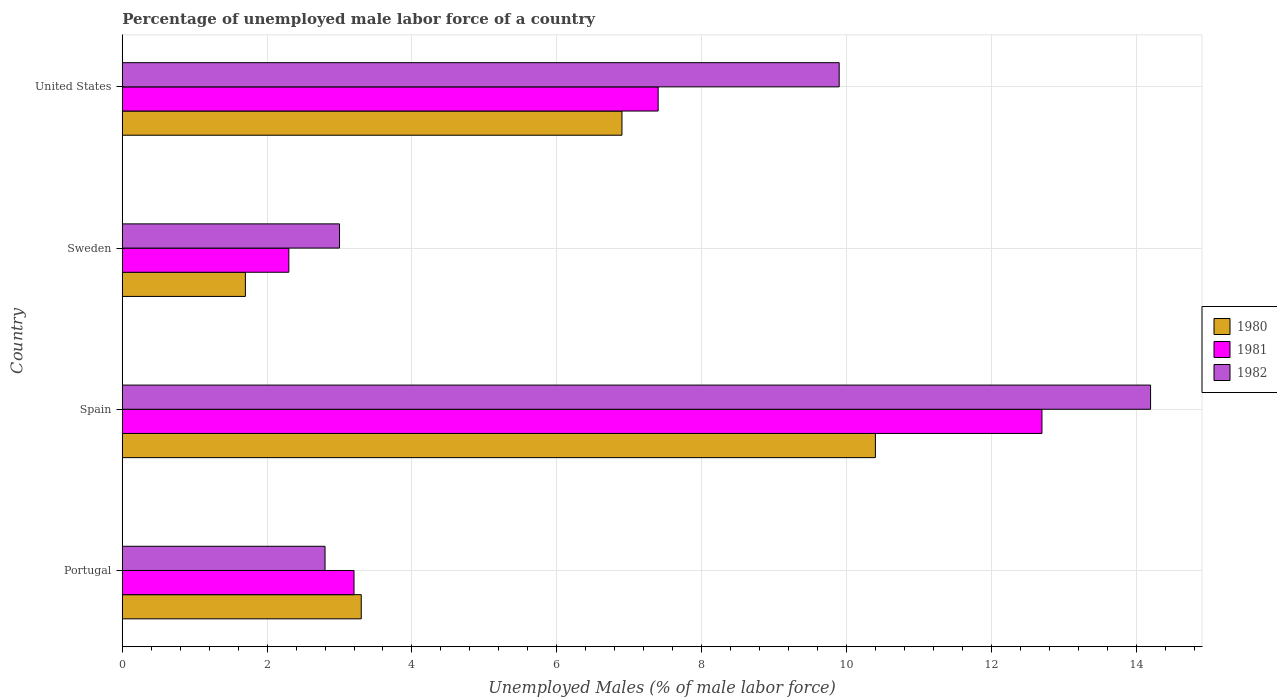How many different coloured bars are there?
Ensure brevity in your answer.  3. How many groups of bars are there?
Offer a terse response. 4. Are the number of bars per tick equal to the number of legend labels?
Keep it short and to the point. Yes. What is the percentage of unemployed male labor force in 1980 in Spain?
Make the answer very short. 10.4. Across all countries, what is the maximum percentage of unemployed male labor force in 1982?
Offer a terse response. 14.2. Across all countries, what is the minimum percentage of unemployed male labor force in 1982?
Give a very brief answer. 2.8. In which country was the percentage of unemployed male labor force in 1982 maximum?
Offer a terse response. Spain. In which country was the percentage of unemployed male labor force in 1982 minimum?
Give a very brief answer. Portugal. What is the total percentage of unemployed male labor force in 1980 in the graph?
Ensure brevity in your answer.  22.3. What is the difference between the percentage of unemployed male labor force in 1981 in Sweden and that in United States?
Your answer should be compact. -5.1. What is the difference between the percentage of unemployed male labor force in 1980 in United States and the percentage of unemployed male labor force in 1982 in Portugal?
Provide a succinct answer. 4.1. What is the average percentage of unemployed male labor force in 1981 per country?
Your answer should be very brief. 6.4. What is the difference between the percentage of unemployed male labor force in 1980 and percentage of unemployed male labor force in 1981 in Sweden?
Give a very brief answer. -0.6. In how many countries, is the percentage of unemployed male labor force in 1981 greater than 4 %?
Give a very brief answer. 2. What is the ratio of the percentage of unemployed male labor force in 1981 in Portugal to that in Sweden?
Your response must be concise. 1.39. What is the difference between the highest and the second highest percentage of unemployed male labor force in 1981?
Keep it short and to the point. 5.3. What is the difference between the highest and the lowest percentage of unemployed male labor force in 1982?
Keep it short and to the point. 11.4. In how many countries, is the percentage of unemployed male labor force in 1981 greater than the average percentage of unemployed male labor force in 1981 taken over all countries?
Offer a terse response. 2. What does the 3rd bar from the top in Portugal represents?
Provide a succinct answer. 1980. What does the 1st bar from the bottom in United States represents?
Ensure brevity in your answer.  1980. Is it the case that in every country, the sum of the percentage of unemployed male labor force in 1980 and percentage of unemployed male labor force in 1982 is greater than the percentage of unemployed male labor force in 1981?
Offer a very short reply. Yes. How many bars are there?
Offer a very short reply. 12. Are all the bars in the graph horizontal?
Give a very brief answer. Yes. What is the difference between two consecutive major ticks on the X-axis?
Give a very brief answer. 2. Does the graph contain any zero values?
Offer a very short reply. No. How many legend labels are there?
Your answer should be very brief. 3. How are the legend labels stacked?
Your response must be concise. Vertical. What is the title of the graph?
Your response must be concise. Percentage of unemployed male labor force of a country. Does "1988" appear as one of the legend labels in the graph?
Your response must be concise. No. What is the label or title of the X-axis?
Ensure brevity in your answer.  Unemployed Males (% of male labor force). What is the Unemployed Males (% of male labor force) of 1980 in Portugal?
Offer a very short reply. 3.3. What is the Unemployed Males (% of male labor force) of 1981 in Portugal?
Provide a short and direct response. 3.2. What is the Unemployed Males (% of male labor force) of 1982 in Portugal?
Keep it short and to the point. 2.8. What is the Unemployed Males (% of male labor force) of 1980 in Spain?
Your answer should be very brief. 10.4. What is the Unemployed Males (% of male labor force) of 1981 in Spain?
Offer a very short reply. 12.7. What is the Unemployed Males (% of male labor force) of 1982 in Spain?
Offer a very short reply. 14.2. What is the Unemployed Males (% of male labor force) of 1980 in Sweden?
Your response must be concise. 1.7. What is the Unemployed Males (% of male labor force) in 1981 in Sweden?
Your answer should be compact. 2.3. What is the Unemployed Males (% of male labor force) in 1982 in Sweden?
Your answer should be very brief. 3. What is the Unemployed Males (% of male labor force) in 1980 in United States?
Your answer should be very brief. 6.9. What is the Unemployed Males (% of male labor force) in 1981 in United States?
Provide a succinct answer. 7.4. What is the Unemployed Males (% of male labor force) in 1982 in United States?
Provide a short and direct response. 9.9. Across all countries, what is the maximum Unemployed Males (% of male labor force) in 1980?
Your answer should be very brief. 10.4. Across all countries, what is the maximum Unemployed Males (% of male labor force) of 1981?
Make the answer very short. 12.7. Across all countries, what is the maximum Unemployed Males (% of male labor force) in 1982?
Give a very brief answer. 14.2. Across all countries, what is the minimum Unemployed Males (% of male labor force) of 1980?
Make the answer very short. 1.7. Across all countries, what is the minimum Unemployed Males (% of male labor force) in 1981?
Offer a terse response. 2.3. Across all countries, what is the minimum Unemployed Males (% of male labor force) in 1982?
Ensure brevity in your answer.  2.8. What is the total Unemployed Males (% of male labor force) in 1980 in the graph?
Ensure brevity in your answer.  22.3. What is the total Unemployed Males (% of male labor force) of 1981 in the graph?
Offer a terse response. 25.6. What is the total Unemployed Males (% of male labor force) of 1982 in the graph?
Offer a very short reply. 29.9. What is the difference between the Unemployed Males (% of male labor force) of 1981 in Portugal and that in Spain?
Keep it short and to the point. -9.5. What is the difference between the Unemployed Males (% of male labor force) in 1982 in Portugal and that in Spain?
Give a very brief answer. -11.4. What is the difference between the Unemployed Males (% of male labor force) of 1980 in Portugal and that in Sweden?
Your answer should be compact. 1.6. What is the difference between the Unemployed Males (% of male labor force) in 1980 in Portugal and that in United States?
Offer a terse response. -3.6. What is the difference between the Unemployed Males (% of male labor force) in 1981 in Portugal and that in United States?
Keep it short and to the point. -4.2. What is the difference between the Unemployed Males (% of male labor force) in 1980 in Spain and that in Sweden?
Provide a succinct answer. 8.7. What is the difference between the Unemployed Males (% of male labor force) of 1981 in Spain and that in Sweden?
Offer a terse response. 10.4. What is the difference between the Unemployed Males (% of male labor force) of 1982 in Spain and that in Sweden?
Keep it short and to the point. 11.2. What is the difference between the Unemployed Males (% of male labor force) in 1981 in Spain and that in United States?
Your response must be concise. 5.3. What is the difference between the Unemployed Males (% of male labor force) of 1981 in Sweden and that in United States?
Provide a succinct answer. -5.1. What is the difference between the Unemployed Males (% of male labor force) in 1980 in Portugal and the Unemployed Males (% of male labor force) in 1981 in Spain?
Give a very brief answer. -9.4. What is the difference between the Unemployed Males (% of male labor force) in 1981 in Portugal and the Unemployed Males (% of male labor force) in 1982 in Spain?
Offer a very short reply. -11. What is the difference between the Unemployed Males (% of male labor force) in 1980 in Portugal and the Unemployed Males (% of male labor force) in 1981 in Sweden?
Your answer should be very brief. 1. What is the difference between the Unemployed Males (% of male labor force) in 1980 in Portugal and the Unemployed Males (% of male labor force) in 1982 in Sweden?
Your answer should be very brief. 0.3. What is the difference between the Unemployed Males (% of male labor force) in 1980 in Portugal and the Unemployed Males (% of male labor force) in 1981 in United States?
Keep it short and to the point. -4.1. What is the difference between the Unemployed Males (% of male labor force) in 1980 in Portugal and the Unemployed Males (% of male labor force) in 1982 in United States?
Provide a short and direct response. -6.6. What is the difference between the Unemployed Males (% of male labor force) in 1981 in Portugal and the Unemployed Males (% of male labor force) in 1982 in United States?
Offer a terse response. -6.7. What is the difference between the Unemployed Males (% of male labor force) in 1980 in Spain and the Unemployed Males (% of male labor force) in 1981 in Sweden?
Your answer should be very brief. 8.1. What is the difference between the Unemployed Males (% of male labor force) of 1980 in Spain and the Unemployed Males (% of male labor force) of 1982 in Sweden?
Provide a short and direct response. 7.4. What is the difference between the Unemployed Males (% of male labor force) of 1981 in Spain and the Unemployed Males (% of male labor force) of 1982 in Sweden?
Your answer should be very brief. 9.7. What is the difference between the Unemployed Males (% of male labor force) of 1980 in Spain and the Unemployed Males (% of male labor force) of 1982 in United States?
Keep it short and to the point. 0.5. What is the difference between the Unemployed Males (% of male labor force) in 1981 in Spain and the Unemployed Males (% of male labor force) in 1982 in United States?
Your answer should be very brief. 2.8. What is the difference between the Unemployed Males (% of male labor force) of 1981 in Sweden and the Unemployed Males (% of male labor force) of 1982 in United States?
Offer a very short reply. -7.6. What is the average Unemployed Males (% of male labor force) of 1980 per country?
Provide a short and direct response. 5.58. What is the average Unemployed Males (% of male labor force) of 1982 per country?
Ensure brevity in your answer.  7.47. What is the difference between the Unemployed Males (% of male labor force) in 1980 and Unemployed Males (% of male labor force) in 1981 in Portugal?
Provide a short and direct response. 0.1. What is the difference between the Unemployed Males (% of male labor force) in 1981 and Unemployed Males (% of male labor force) in 1982 in Portugal?
Offer a very short reply. 0.4. What is the difference between the Unemployed Males (% of male labor force) in 1980 and Unemployed Males (% of male labor force) in 1982 in Sweden?
Provide a succinct answer. -1.3. What is the difference between the Unemployed Males (% of male labor force) in 1980 and Unemployed Males (% of male labor force) in 1982 in United States?
Provide a succinct answer. -3. What is the difference between the Unemployed Males (% of male labor force) in 1981 and Unemployed Males (% of male labor force) in 1982 in United States?
Offer a very short reply. -2.5. What is the ratio of the Unemployed Males (% of male labor force) in 1980 in Portugal to that in Spain?
Give a very brief answer. 0.32. What is the ratio of the Unemployed Males (% of male labor force) of 1981 in Portugal to that in Spain?
Your answer should be compact. 0.25. What is the ratio of the Unemployed Males (% of male labor force) in 1982 in Portugal to that in Spain?
Your response must be concise. 0.2. What is the ratio of the Unemployed Males (% of male labor force) of 1980 in Portugal to that in Sweden?
Keep it short and to the point. 1.94. What is the ratio of the Unemployed Males (% of male labor force) in 1981 in Portugal to that in Sweden?
Your answer should be compact. 1.39. What is the ratio of the Unemployed Males (% of male labor force) of 1980 in Portugal to that in United States?
Your answer should be very brief. 0.48. What is the ratio of the Unemployed Males (% of male labor force) in 1981 in Portugal to that in United States?
Offer a terse response. 0.43. What is the ratio of the Unemployed Males (% of male labor force) of 1982 in Portugal to that in United States?
Your answer should be very brief. 0.28. What is the ratio of the Unemployed Males (% of male labor force) in 1980 in Spain to that in Sweden?
Your answer should be compact. 6.12. What is the ratio of the Unemployed Males (% of male labor force) of 1981 in Spain to that in Sweden?
Provide a succinct answer. 5.52. What is the ratio of the Unemployed Males (% of male labor force) in 1982 in Spain to that in Sweden?
Your response must be concise. 4.73. What is the ratio of the Unemployed Males (% of male labor force) of 1980 in Spain to that in United States?
Give a very brief answer. 1.51. What is the ratio of the Unemployed Males (% of male labor force) in 1981 in Spain to that in United States?
Provide a succinct answer. 1.72. What is the ratio of the Unemployed Males (% of male labor force) in 1982 in Spain to that in United States?
Ensure brevity in your answer.  1.43. What is the ratio of the Unemployed Males (% of male labor force) of 1980 in Sweden to that in United States?
Provide a short and direct response. 0.25. What is the ratio of the Unemployed Males (% of male labor force) of 1981 in Sweden to that in United States?
Provide a short and direct response. 0.31. What is the ratio of the Unemployed Males (% of male labor force) of 1982 in Sweden to that in United States?
Make the answer very short. 0.3. What is the difference between the highest and the second highest Unemployed Males (% of male labor force) in 1980?
Give a very brief answer. 3.5. What is the difference between the highest and the second highest Unemployed Males (% of male labor force) of 1982?
Keep it short and to the point. 4.3. What is the difference between the highest and the lowest Unemployed Males (% of male labor force) in 1980?
Ensure brevity in your answer.  8.7. What is the difference between the highest and the lowest Unemployed Males (% of male labor force) in 1981?
Offer a very short reply. 10.4. 